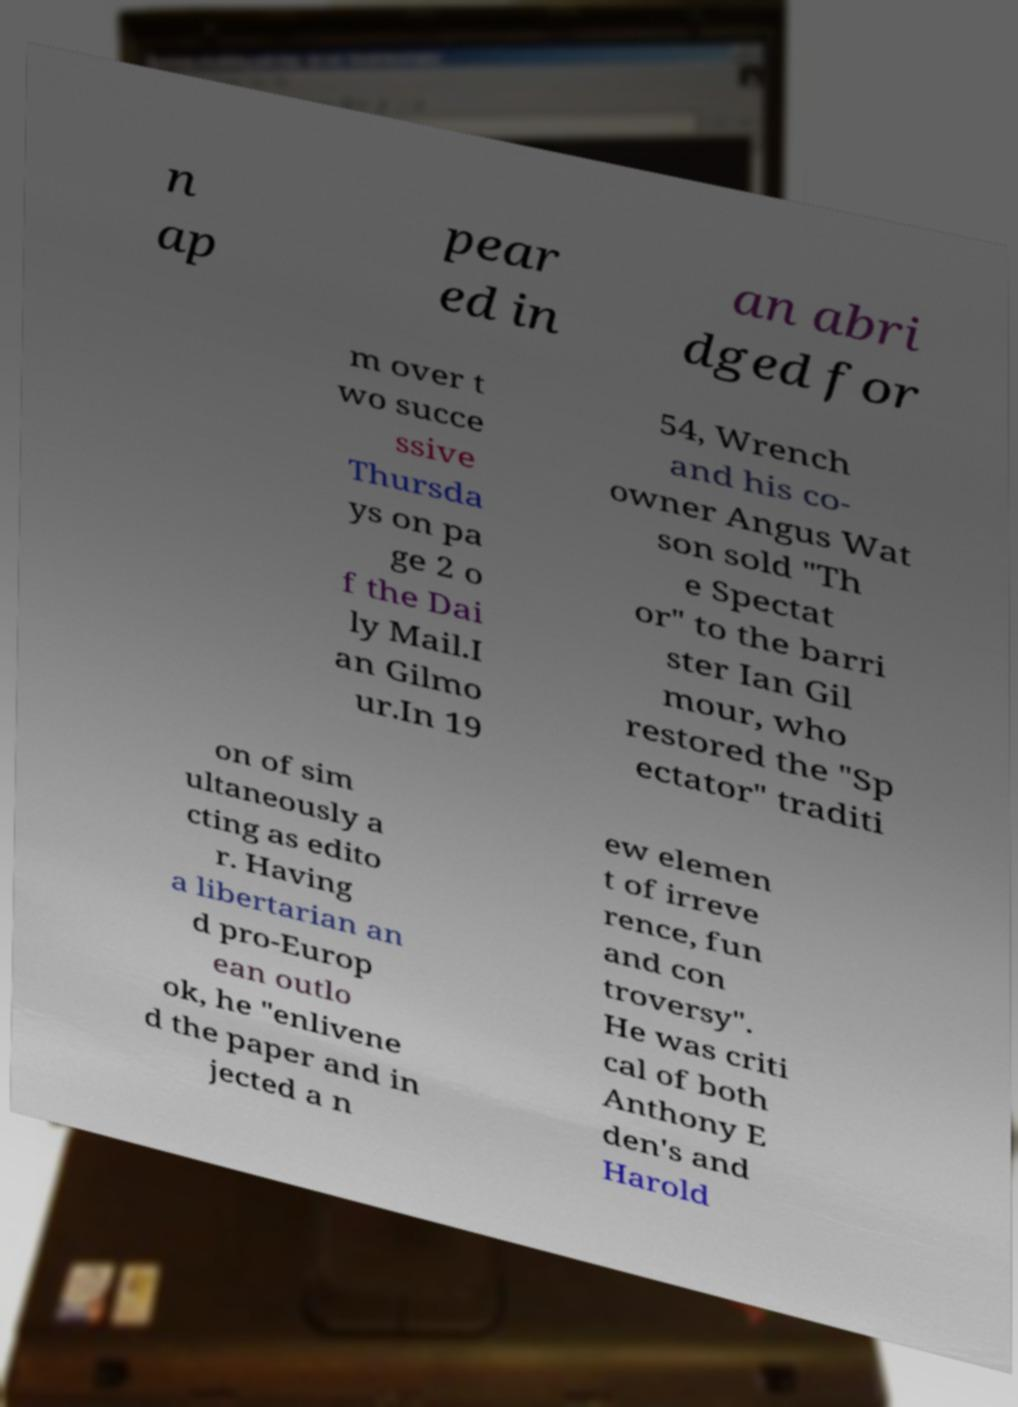There's text embedded in this image that I need extracted. Can you transcribe it verbatim? n ap pear ed in an abri dged for m over t wo succe ssive Thursda ys on pa ge 2 o f the Dai ly Mail.I an Gilmo ur.In 19 54, Wrench and his co- owner Angus Wat son sold "Th e Spectat or" to the barri ster Ian Gil mour, who restored the "Sp ectator" traditi on of sim ultaneously a cting as edito r. Having a libertarian an d pro-Europ ean outlo ok, he "enlivene d the paper and in jected a n ew elemen t of irreve rence, fun and con troversy". He was criti cal of both Anthony E den's and Harold 